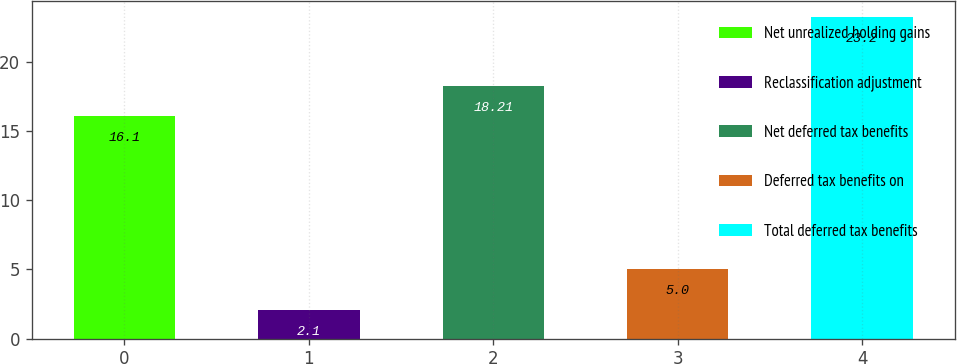<chart> <loc_0><loc_0><loc_500><loc_500><bar_chart><fcel>Net unrealized holding gains<fcel>Reclassification adjustment<fcel>Net deferred tax benefits<fcel>Deferred tax benefits on<fcel>Total deferred tax benefits<nl><fcel>16.1<fcel>2.1<fcel>18.21<fcel>5<fcel>23.2<nl></chart> 